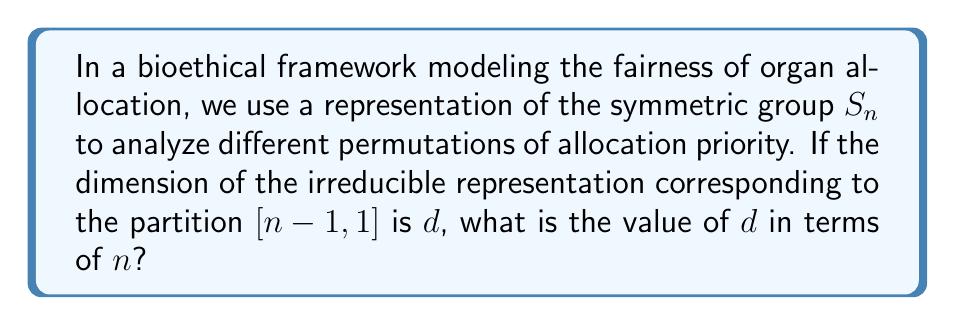Teach me how to tackle this problem. To solve this problem, we'll follow these steps:

1) In representation theory of the symmetric group $S_n$, irreducible representations correspond to partitions of $n$.

2) The partition $[n-1,1]$ corresponds to the standard representation of $S_n$.

3) The dimension of an irreducible representation of $S_n$ can be calculated using the hook length formula:

   $$d_\lambda = \frac{n!}{\prod_{(i,j) \in \lambda} h_{ij}}$$

   where $\lambda$ is the partition and $h_{ij}$ is the hook length of the cell $(i,j)$ in the Young diagram.

4) For the partition $[n-1,1]$, the Young diagram looks like:

   ```
   [asy]
   unitsize(1cm);
   for(int i=0; i<4; ++i) draw((0,i)--(4,i));
   for(int i=0; i<5; ++i) draw((i,0)--(i,1));
   draw((0,1)--(1,1));
   label("$n-1$", (2,0.5));
   label("1", (0.5,1.5));
   [/asy]
   ```

5) The hook lengths for this diagram are:
   - $n$ for the first box in the first row
   - $1,2,3,...,n-2$ for the remaining boxes in the first row
   - $1$ for the box in the second row

6) Applying the hook length formula:

   $$d = \frac{n!}{n \cdot (n-2)! \cdot 1 \cdot 1} = \frac{n!}{n \cdot (n-2)!}$$

7) Simplify:
   $$d = \frac{n \cdot (n-1) \cdot (n-2)!}{n \cdot (n-2)!} = n-1$$

Therefore, the dimension of the irreducible representation corresponding to the partition $[n-1,1]$ is $n-1$.
Answer: $n-1$ 